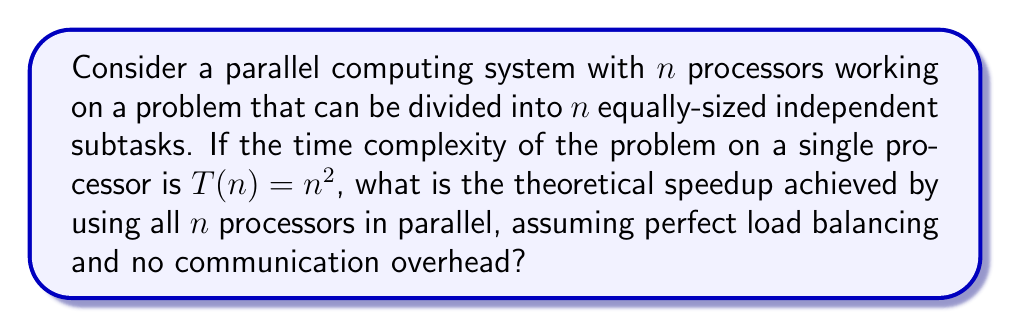Help me with this question. To solve this problem, we need to understand the concept of speedup in parallel computing and apply Amdahl's Law.

1. First, let's define speedup:
   Speedup is the ratio of the time taken to solve a problem on a single processor to the time taken to solve the same problem on $n$ processors in parallel.

   $$ S(n) = \frac{T(1)}{T(n)} $$

   where $S(n)$ is the speedup, $T(1)$ is the time on a single processor, and $T(n)$ is the time on $n$ processors.

2. In this case, we're given that $T(n) = n^2$ for a single processor. So, the time to solve the entire problem on one processor is:

   $$ T(1) = n^2 $$

3. Now, when we use $n$ processors in parallel, each processor will work on a subtask of size $\frac{n}{n} = 1$. The time complexity for each subtask is:

   $$ T(\frac{n}{n}) = T(1) = 1^2 = 1 $$

4. Since we assume perfect load balancing and no communication overhead, the time to solve the entire problem in parallel is equal to the time to solve one subtask:

   $$ T(n) = 1 $$

5. Now we can calculate the speedup:

   $$ S(n) = \frac{T(1)}{T(n)} = \frac{n^2}{1} = n^2 $$

This result shows that the theoretical speedup is quadratic in the number of processors, which is the best possible scenario for this problem.

It's important to note that in real-world scenarios, perfect speedup is rarely achieved due to factors such as communication overhead, load imbalance, and parts of the problem that cannot be parallelized.
Answer: The theoretical speedup achieved is $n^2$. 